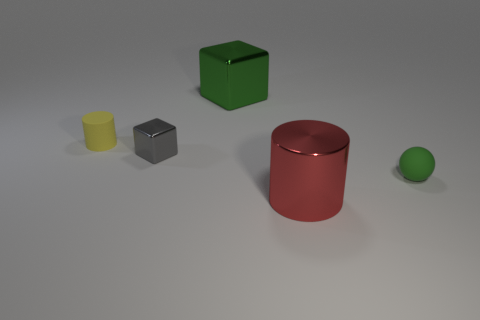Add 1 green rubber blocks. How many objects exist? 6 Subtract all spheres. How many objects are left? 4 Add 2 small yellow cylinders. How many small yellow cylinders are left? 3 Add 1 tiny gray cubes. How many tiny gray cubes exist? 2 Subtract 0 yellow balls. How many objects are left? 5 Subtract all yellow cylinders. Subtract all small gray things. How many objects are left? 3 